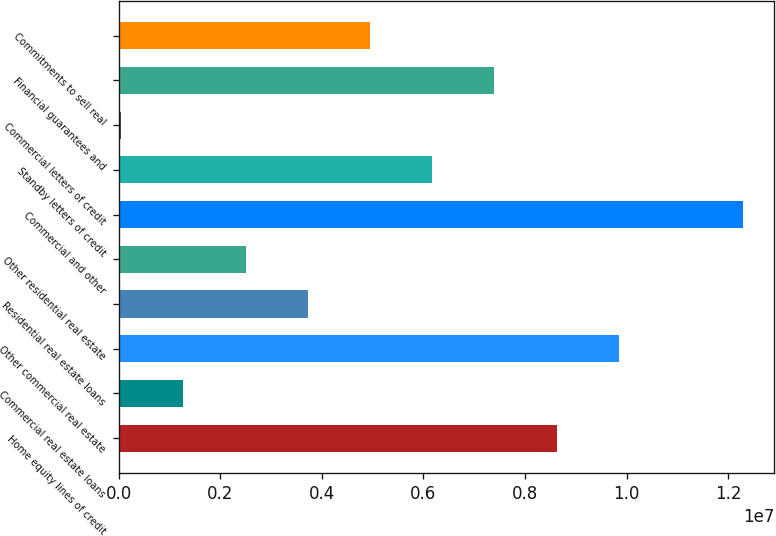Convert chart. <chart><loc_0><loc_0><loc_500><loc_500><bar_chart><fcel>Home equity lines of credit<fcel>Commercial real estate loans<fcel>Other commercial real estate<fcel>Residential real estate loans<fcel>Other residential real estate<fcel>Commercial and other<fcel>Standby letters of credit<fcel>Commercial letters of credit<fcel>Financial guarantees and<fcel>Commitments to sell real<nl><fcel>8.62235e+06<fcel>1.2701e+06<fcel>9.84772e+06<fcel>3.72085e+06<fcel>2.49547e+06<fcel>1.22985e+07<fcel>6.1716e+06<fcel>44723<fcel>7.39697e+06<fcel>4.94622e+06<nl></chart> 